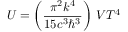Convert formula to latex. <formula><loc_0><loc_0><loc_500><loc_500>U = \left ( { \frac { \pi ^ { 2 } k ^ { 4 } } { 1 5 c ^ { 3 } \hbar { ^ } { 3 } } } \right ) \, V T ^ { 4 }</formula> 